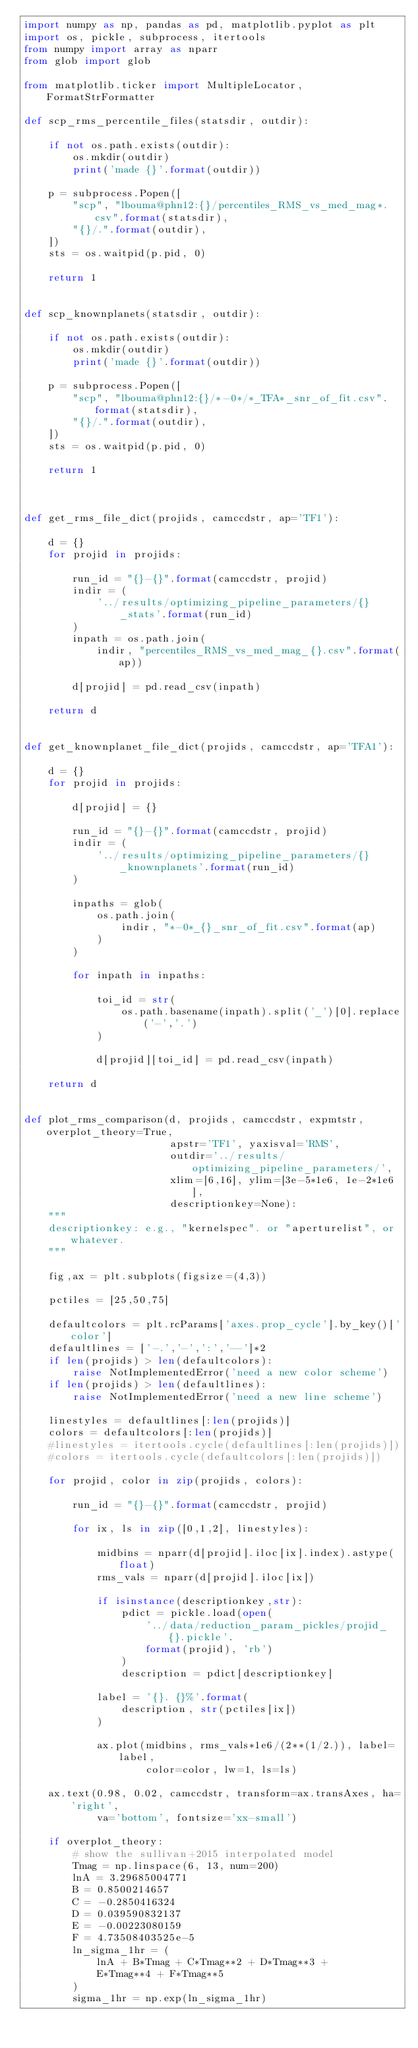Convert code to text. <code><loc_0><loc_0><loc_500><loc_500><_Python_>import numpy as np, pandas as pd, matplotlib.pyplot as plt
import os, pickle, subprocess, itertools
from numpy import array as nparr
from glob import glob

from matplotlib.ticker import MultipleLocator, FormatStrFormatter

def scp_rms_percentile_files(statsdir, outdir):

    if not os.path.exists(outdir):
        os.mkdir(outdir)
        print('made {}'.format(outdir))

    p = subprocess.Popen([
        "scp", "lbouma@phn12:{}/percentiles_RMS_vs_med_mag*.csv".format(statsdir),
        "{}/.".format(outdir),
    ])
    sts = os.waitpid(p.pid, 0)

    return 1


def scp_knownplanets(statsdir, outdir):

    if not os.path.exists(outdir):
        os.mkdir(outdir)
        print('made {}'.format(outdir))

    p = subprocess.Popen([
        "scp", "lbouma@phn12:{}/*-0*/*_TFA*_snr_of_fit.csv".format(statsdir),
        "{}/.".format(outdir),
    ])
    sts = os.waitpid(p.pid, 0)

    return 1



def get_rms_file_dict(projids, camccdstr, ap='TF1'):

    d = {}
    for projid in projids:

        run_id = "{}-{}".format(camccdstr, projid)
        indir = (
            '../results/optimizing_pipeline_parameters/{}_stats'.format(run_id)
        )
        inpath = os.path.join(
            indir, "percentiles_RMS_vs_med_mag_{}.csv".format(ap))

        d[projid] = pd.read_csv(inpath)

    return d


def get_knownplanet_file_dict(projids, camccdstr, ap='TFA1'):

    d = {}
    for projid in projids:

        d[projid] = {}

        run_id = "{}-{}".format(camccdstr, projid)
        indir = (
            '../results/optimizing_pipeline_parameters/{}_knownplanets'.format(run_id)
        )

        inpaths = glob(
            os.path.join(
                indir, "*-0*_{}_snr_of_fit.csv".format(ap)
            )
        )

        for inpath in inpaths:

            toi_id = str(
                os.path.basename(inpath).split('_')[0].replace('-','.')
            )

            d[projid][toi_id] = pd.read_csv(inpath)

    return d


def plot_rms_comparison(d, projids, camccdstr, expmtstr, overplot_theory=True,
                        apstr='TF1', yaxisval='RMS',
                        outdir='../results/optimizing_pipeline_parameters/',
                        xlim=[6,16], ylim=[3e-5*1e6, 1e-2*1e6],
                        descriptionkey=None):
    """
    descriptionkey: e.g., "kernelspec". or "aperturelist", or whatever.
    """

    fig,ax = plt.subplots(figsize=(4,3))

    pctiles = [25,50,75]

    defaultcolors = plt.rcParams['axes.prop_cycle'].by_key()['color']
    defaultlines = ['-.','-',':','--']*2
    if len(projids) > len(defaultcolors):
        raise NotImplementedError('need a new color scheme')
    if len(projids) > len(defaultlines):
        raise NotImplementedError('need a new line scheme')

    linestyles = defaultlines[:len(projids)]
    colors = defaultcolors[:len(projids)]
    #linestyles = itertools.cycle(defaultlines[:len(projids)])
    #colors = itertools.cycle(defaultcolors[:len(projids)])

    for projid, color in zip(projids, colors):

        run_id = "{}-{}".format(camccdstr, projid)

        for ix, ls in zip([0,1,2], linestyles):

            midbins = nparr(d[projid].iloc[ix].index).astype(float)
            rms_vals = nparr(d[projid].iloc[ix])

            if isinstance(descriptionkey,str):
                pdict = pickle.load(open(
                    '../data/reduction_param_pickles/projid_{}.pickle'.
                    format(projid), 'rb')
                )
                description = pdict[descriptionkey]

            label = '{}. {}%'.format(
                description, str(pctiles[ix])
            )

            ax.plot(midbins, rms_vals*1e6/(2**(1/2.)), label=label,
                    color=color, lw=1, ls=ls)

    ax.text(0.98, 0.02, camccdstr, transform=ax.transAxes, ha='right',
            va='bottom', fontsize='xx-small')

    if overplot_theory:
        # show the sullivan+2015 interpolated model
        Tmag = np.linspace(6, 13, num=200)
        lnA = 3.29685004771
        B = 0.8500214657
        C = -0.2850416324
        D = 0.039590832137
        E = -0.00223080159
        F = 4.73508403525e-5
        ln_sigma_1hr = (
            lnA + B*Tmag + C*Tmag**2 + D*Tmag**3 +
            E*Tmag**4 + F*Tmag**5
        )
        sigma_1hr = np.exp(ln_sigma_1hr)</code> 